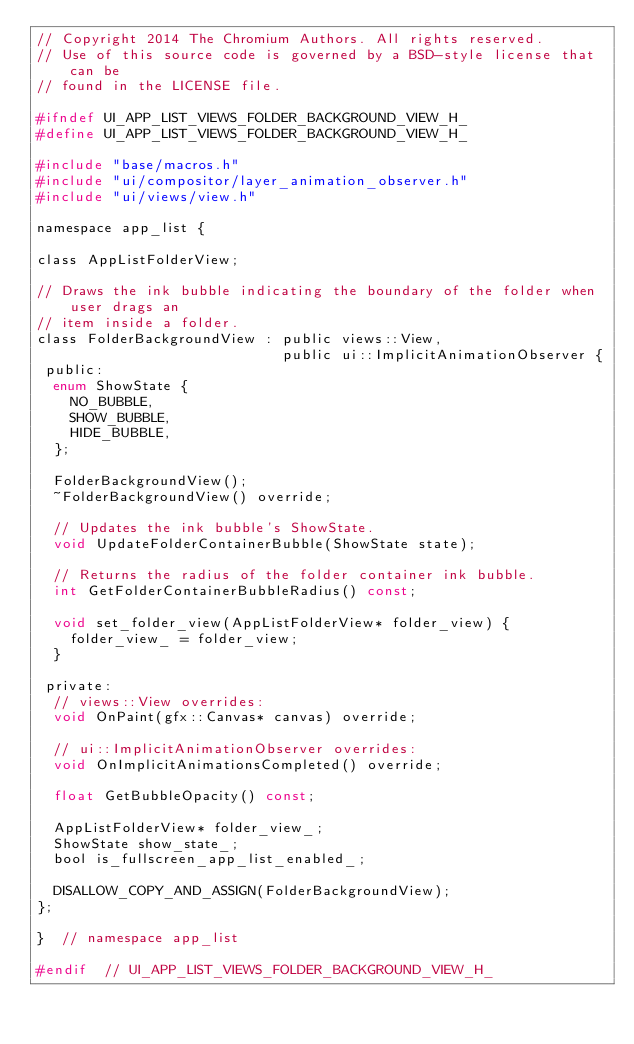Convert code to text. <code><loc_0><loc_0><loc_500><loc_500><_C_>// Copyright 2014 The Chromium Authors. All rights reserved.
// Use of this source code is governed by a BSD-style license that can be
// found in the LICENSE file.

#ifndef UI_APP_LIST_VIEWS_FOLDER_BACKGROUND_VIEW_H_
#define UI_APP_LIST_VIEWS_FOLDER_BACKGROUND_VIEW_H_

#include "base/macros.h"
#include "ui/compositor/layer_animation_observer.h"
#include "ui/views/view.h"

namespace app_list {

class AppListFolderView;

// Draws the ink bubble indicating the boundary of the folder when user drags an
// item inside a folder.
class FolderBackgroundView : public views::View,
                             public ui::ImplicitAnimationObserver {
 public:
  enum ShowState {
    NO_BUBBLE,
    SHOW_BUBBLE,
    HIDE_BUBBLE,
  };

  FolderBackgroundView();
  ~FolderBackgroundView() override;

  // Updates the ink bubble's ShowState.
  void UpdateFolderContainerBubble(ShowState state);

  // Returns the radius of the folder container ink bubble.
  int GetFolderContainerBubbleRadius() const;

  void set_folder_view(AppListFolderView* folder_view) {
    folder_view_ = folder_view;
  }

 private:
  // views::View overrides:
  void OnPaint(gfx::Canvas* canvas) override;

  // ui::ImplicitAnimationObserver overrides:
  void OnImplicitAnimationsCompleted() override;

  float GetBubbleOpacity() const;

  AppListFolderView* folder_view_;
  ShowState show_state_;
  bool is_fullscreen_app_list_enabled_;

  DISALLOW_COPY_AND_ASSIGN(FolderBackgroundView);
};

}  // namespace app_list

#endif  // UI_APP_LIST_VIEWS_FOLDER_BACKGROUND_VIEW_H_
</code> 